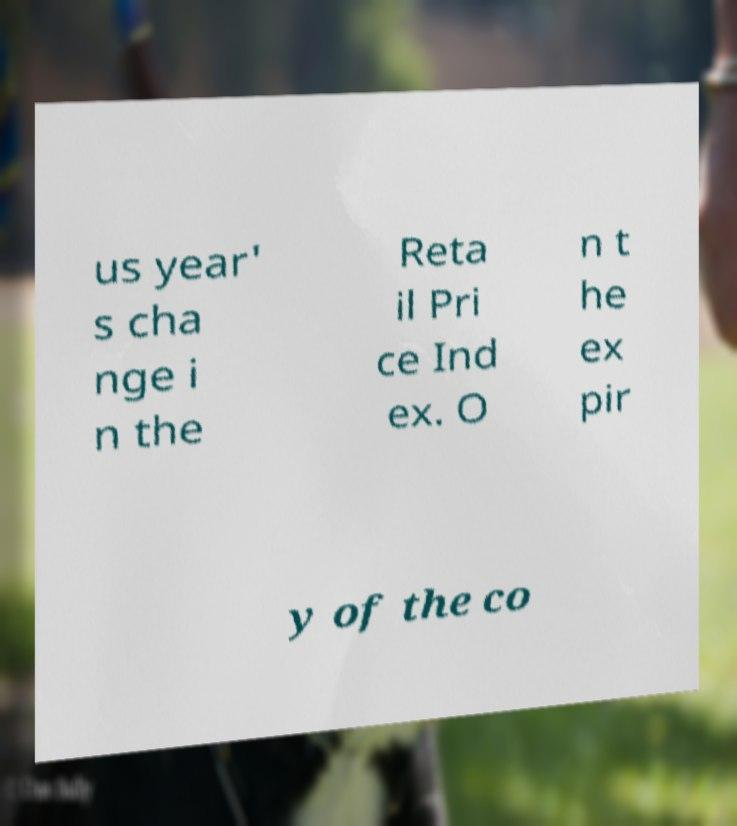Please read and relay the text visible in this image. What does it say? us year' s cha nge i n the Reta il Pri ce Ind ex. O n t he ex pir y of the co 